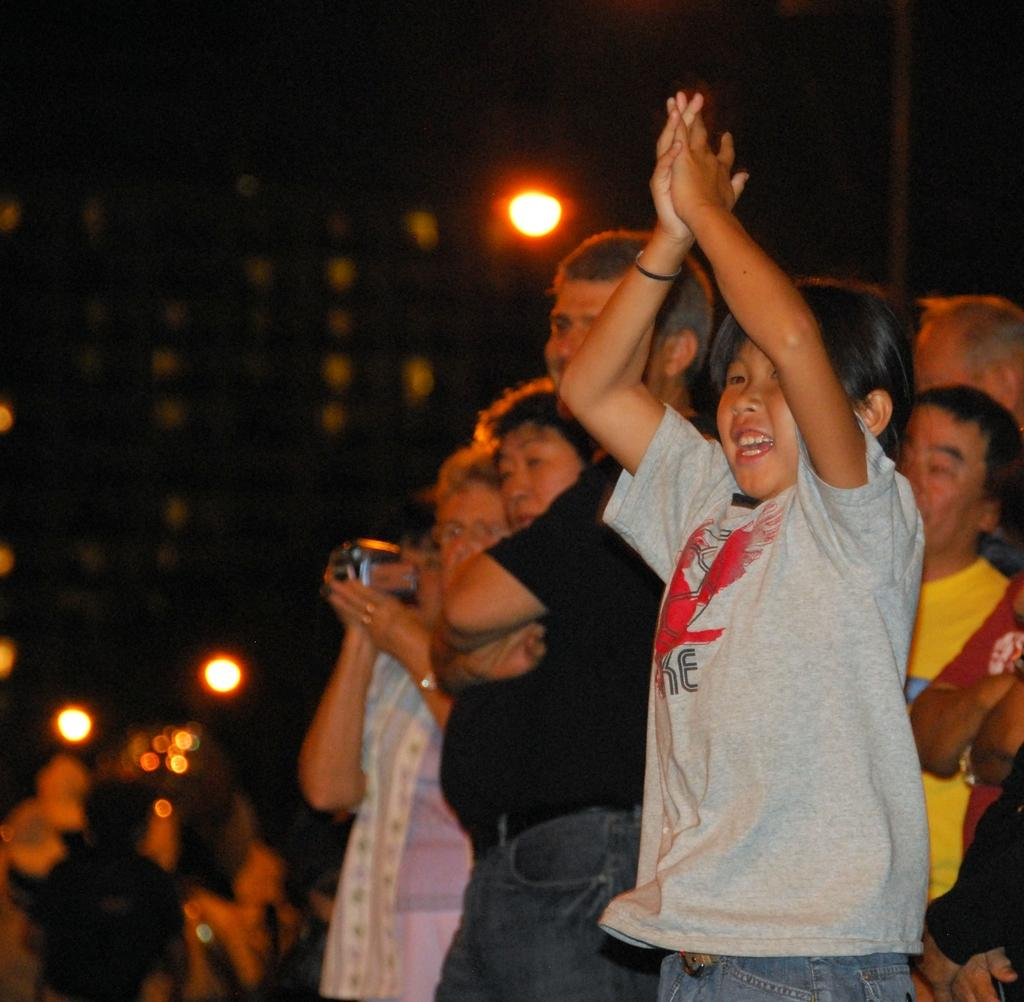How many people are present in the image? There are multiple persons in the image. What can be seen in the middle of the image? There are lights in the middle of the image. What type of comb is being used by the person in the image? There is no comb present in the image. What material is the brass instrument made of in the image? There is no brass instrument present in the image. 